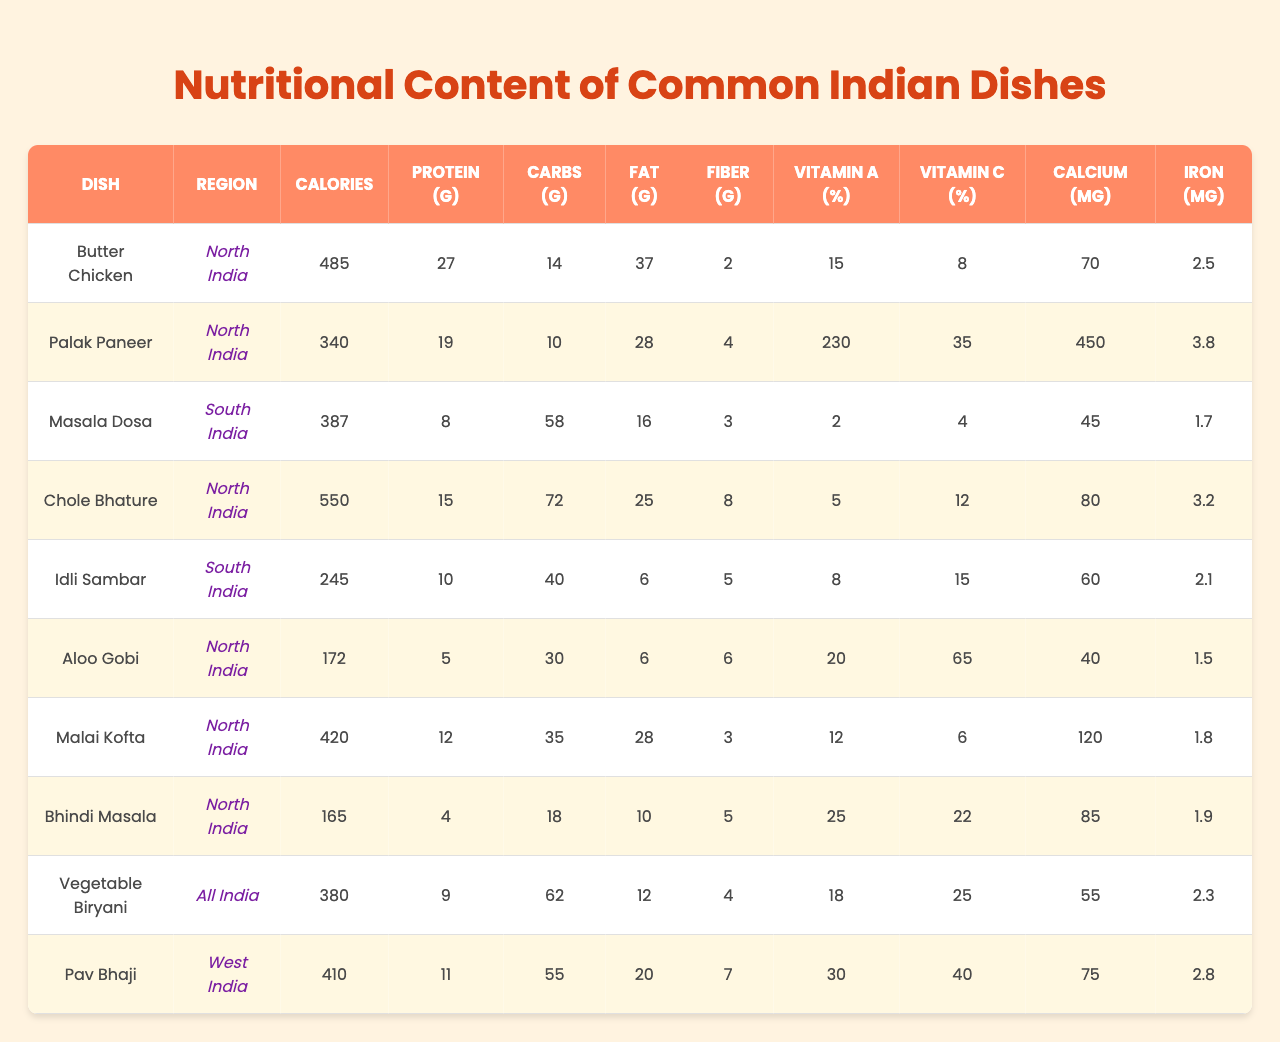What dish has the highest calorie content? By inspecting the "Calories" column, "Chole Bhature" shows the highest value of 550 calories compared to others.
Answer: Chole Bhature Which dish has the most vitamin A? Looking at the "Vitamin A" column, "Palak Paneer" has the highest percentage at 230%, more than any other dish.
Answer: Palak Paneer How many grams of protein are in Butter Chicken? The "Protein" column indicates that "Butter Chicken" contains 27 grams of protein.
Answer: 27 grams What is the total amount of carbs in Idli Sambar and Masala Dosa combined? Adding the "Carbs" values from both dishes, 40 (Idli Sambar) + 58 (Masala Dosa) = 98 grams of carbs in total.
Answer: 98 grams Does Aloo Gobi contain more fiber than Bhindi Masala? The "Fiber" column shows Aloo Gobi with 6 grams and Bhindi Masala with 5 grams, confirming that Aloo Gobi has more fiber.
Answer: Yes What is the average calcium content of dishes from North India? The total calcium content for North Indian dishes is 70 + 450 + 80 + 120 + 40 + 85 = 845 mg. There are 6 dishes, so the average is 845 / 6 ≈ 140.83 mg.
Answer: 140.83 mg Is the fat content in Vegetable Biryani higher than in Pav Bhaji? Vegetable Biryani has 12 grams of fat and Pav Bhaji has 20 grams, thus Vegetable Biryani has less fat.
Answer: No What is the difference in iron content between Chole Bhature and Palak Paneer? The iron content for Chole Bhature is 3.2 mg and for Palak Paneer is 3.8 mg. So, the difference is 3.8 - 3.2 = 0.6 mg.
Answer: 0.6 mg Which dish has the lowest protein content? Checking the "Protein" column, "Bhindi Masala" has the lowest protein content at 4 grams compared to other dishes.
Answer: Bhindi Masala What is the total calorie content of all dishes listed? Summing all the calorie counts: 485 + 340 + 387 + 550 + 245 + 172 + 420 + 165 + 380 + 410 = 3,322 calories.
Answer: 3,322 calories 